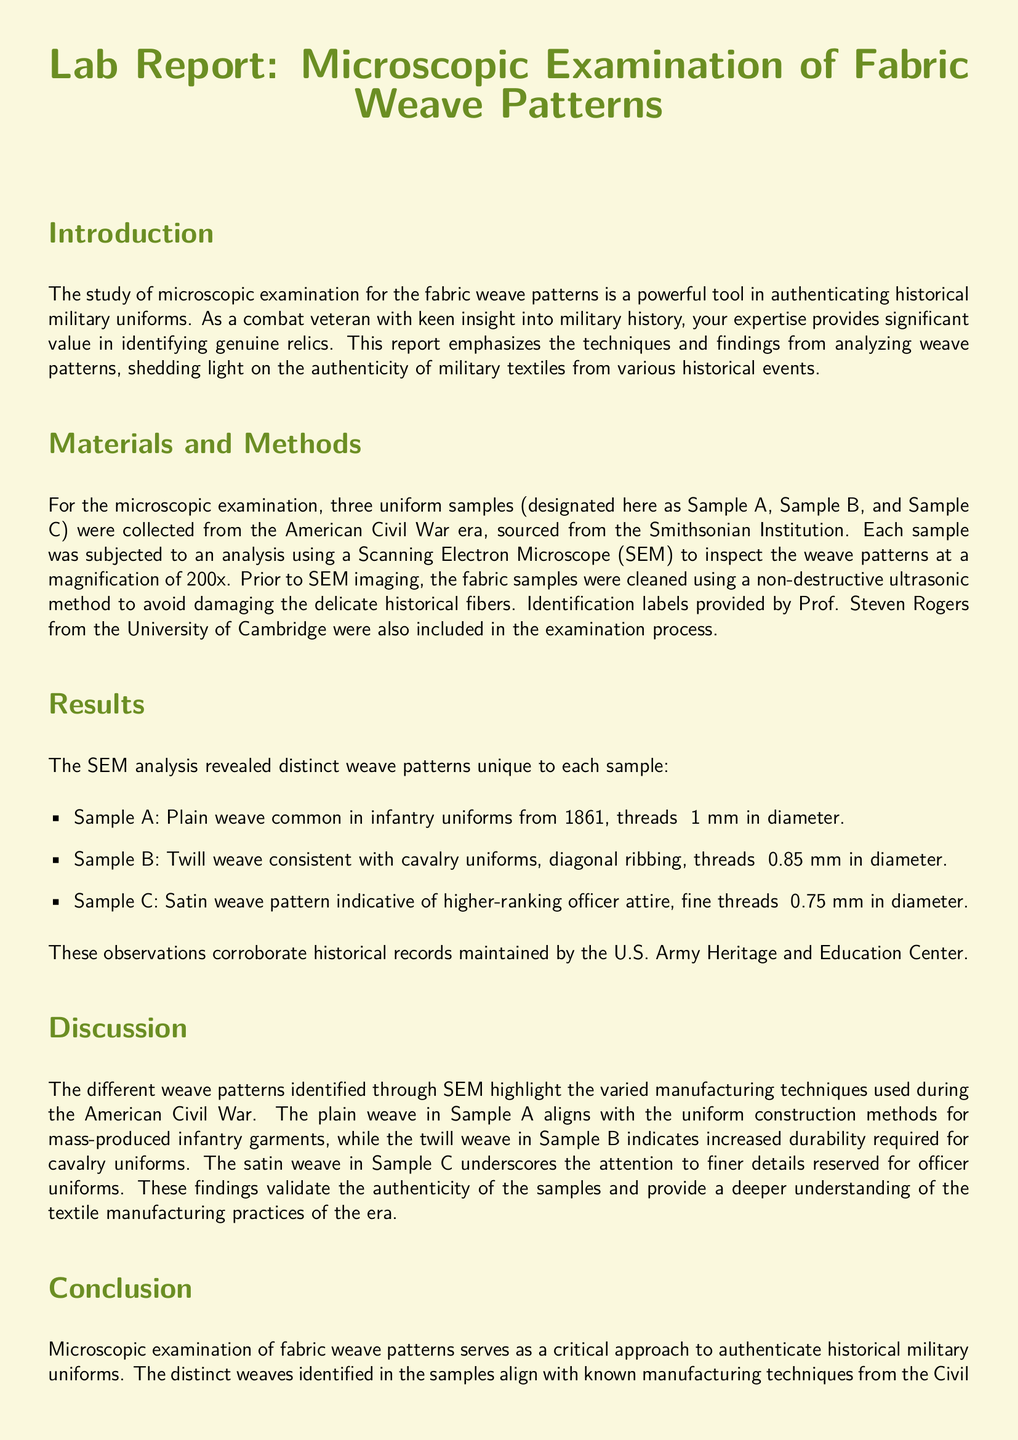What are the three samples analyzed in the report? The report documents the analysis of three uniform samples designated as Sample A, Sample B, and Sample C.
Answer: Sample A, Sample B, Sample C What was the magnification used in the SEM analysis? The document explicitly states that the SEM analysis was conducted at a magnification of 200x.
Answer: 200x What type of weave did Sample B exhibit? The findings explicitly describe Sample B as having a twill weave consistent with cavalry uniforms.
Answer: Twill weave Who provided the identification labels for the fabric samples? The report indicates that the identification labels were provided by Prof. Steven Rogers from the University of Cambridge.
Answer: Prof. Steven Rogers What era do the uniform samples date back to? The introduction specifies that the uniform samples were sourced from the American Civil War era.
Answer: American Civil War What conclusion is drawn regarding the authenticity of the samples? The conclusion states that the distinct weaves align with known manufacturing techniques from the Civil War period, confirming their authenticity.
Answer: Confirming their authenticity Which weave pattern indicates higher-ranking officer attire? The report identifies the satin weave pattern as indicative of higher-ranking officer attire.
Answer: Satin weave What is the purpose of this lab report? The document's introduction explains that the lab report emphasizes techniques and findings in the analysis of weave patterns for the purpose of authenticating historical military uniforms.
Answer: Authenticating historical military uniforms 